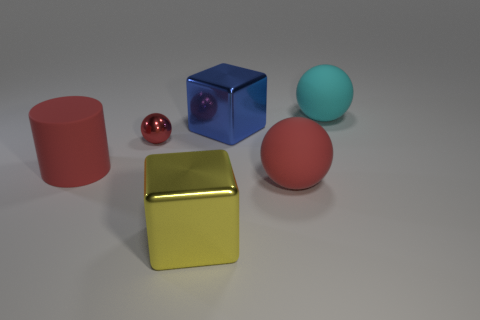Add 2 large yellow objects. How many objects exist? 8 Subtract all cylinders. How many objects are left? 5 Subtract 0 purple spheres. How many objects are left? 6 Subtract all big yellow matte blocks. Subtract all big blue metallic cubes. How many objects are left? 5 Add 1 cyan matte things. How many cyan matte things are left? 2 Add 5 large brown spheres. How many large brown spheres exist? 5 